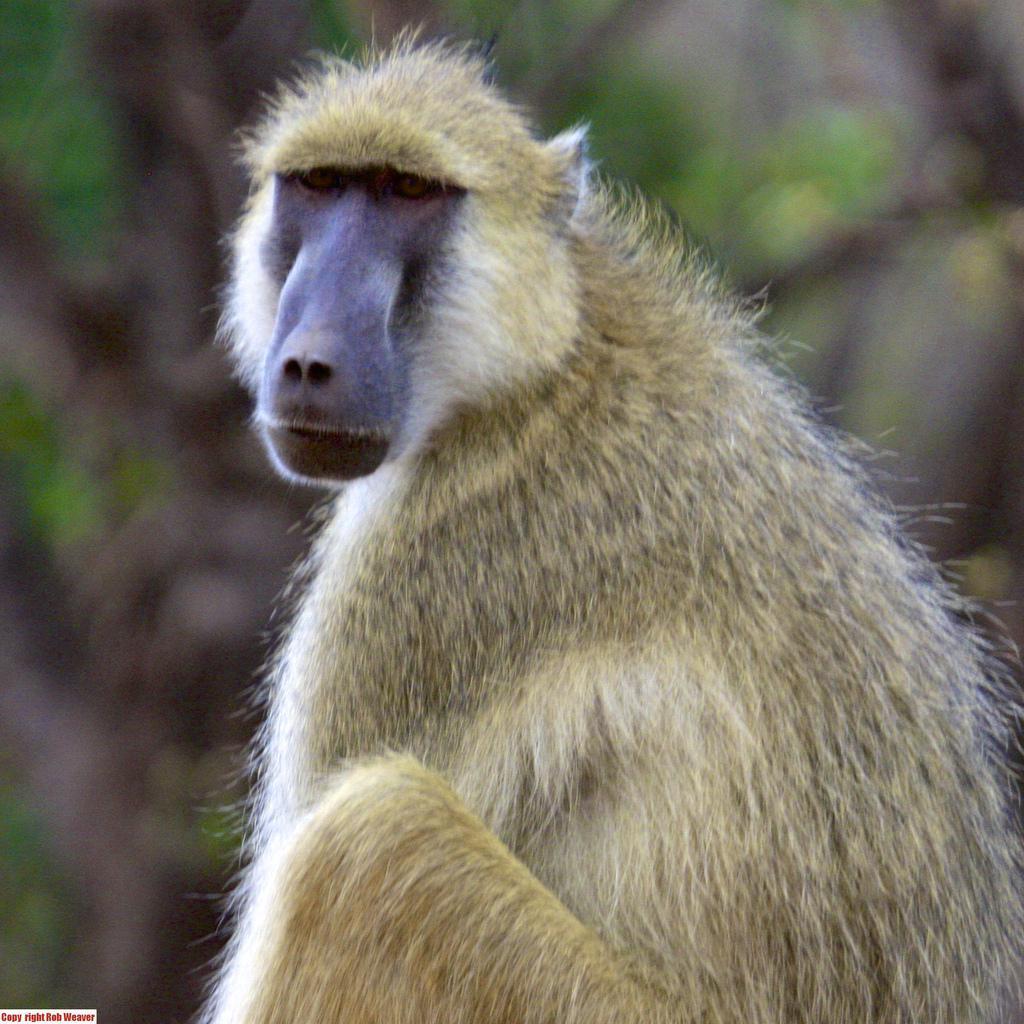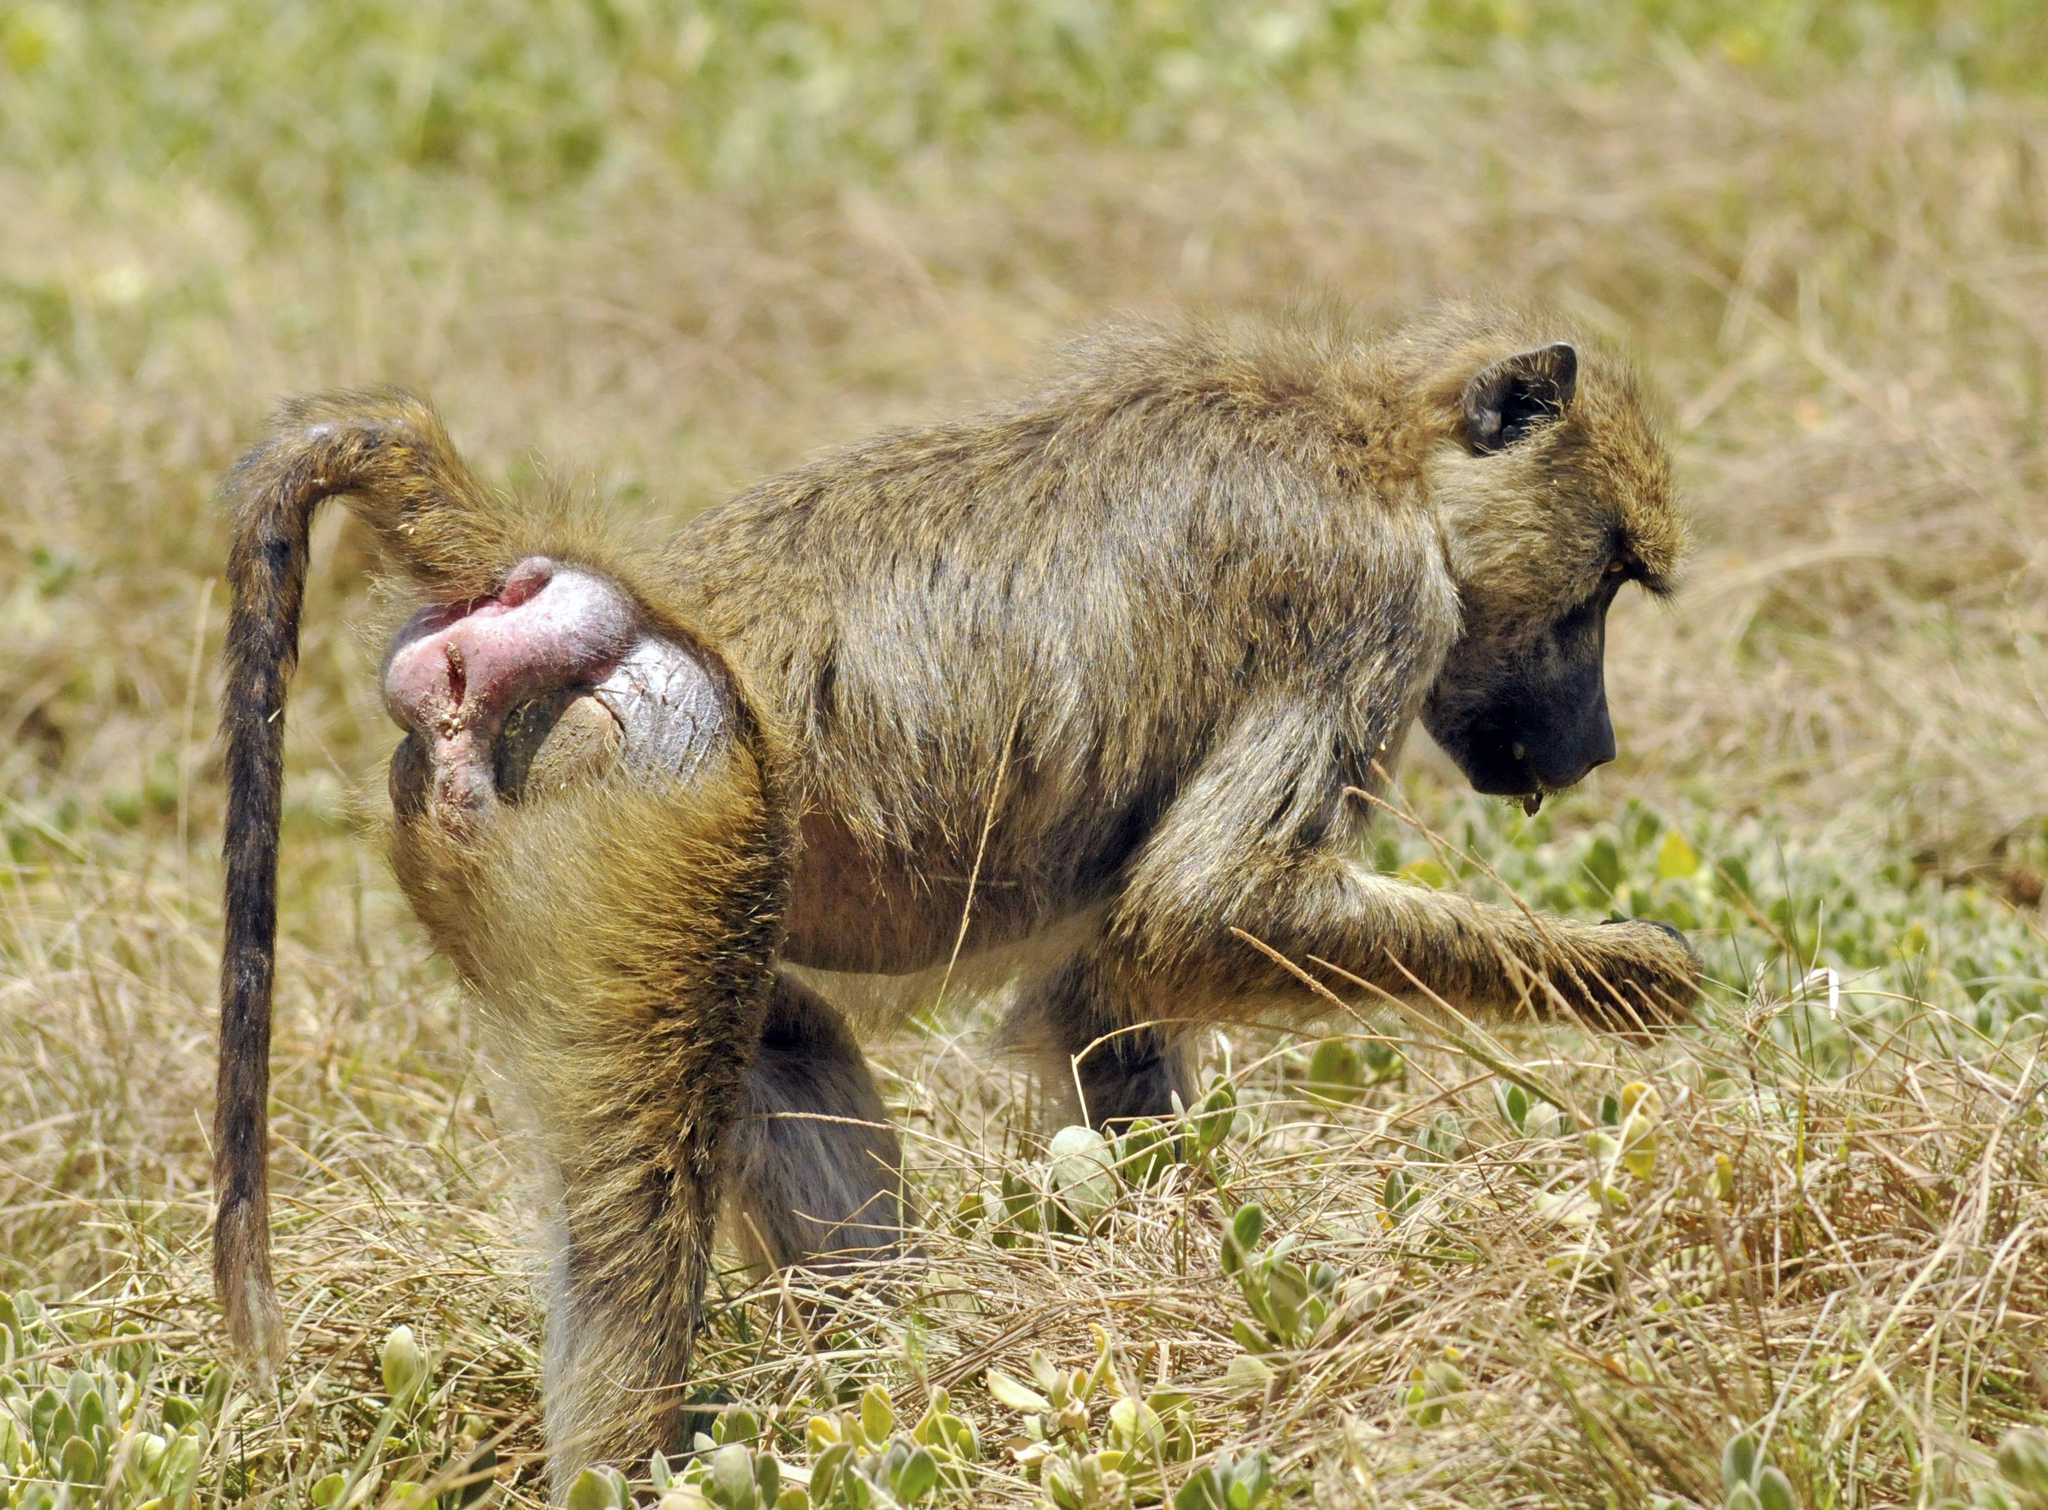The first image is the image on the left, the second image is the image on the right. Assess this claim about the two images: "At least one monkey is on all fours.". Correct or not? Answer yes or no. Yes. 